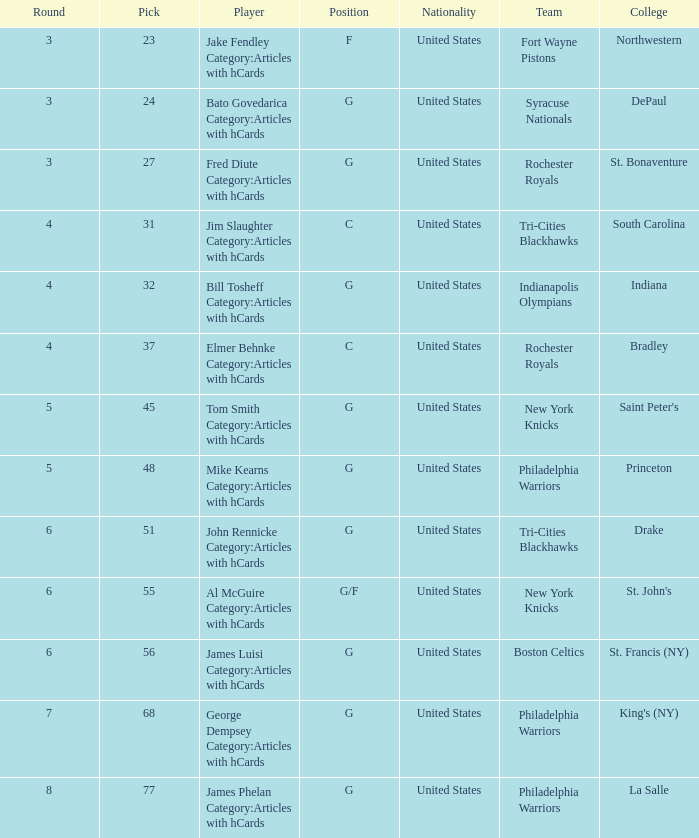How many picks in total are there for players from drake on the tri-cities blackhawks team? 51.0. 